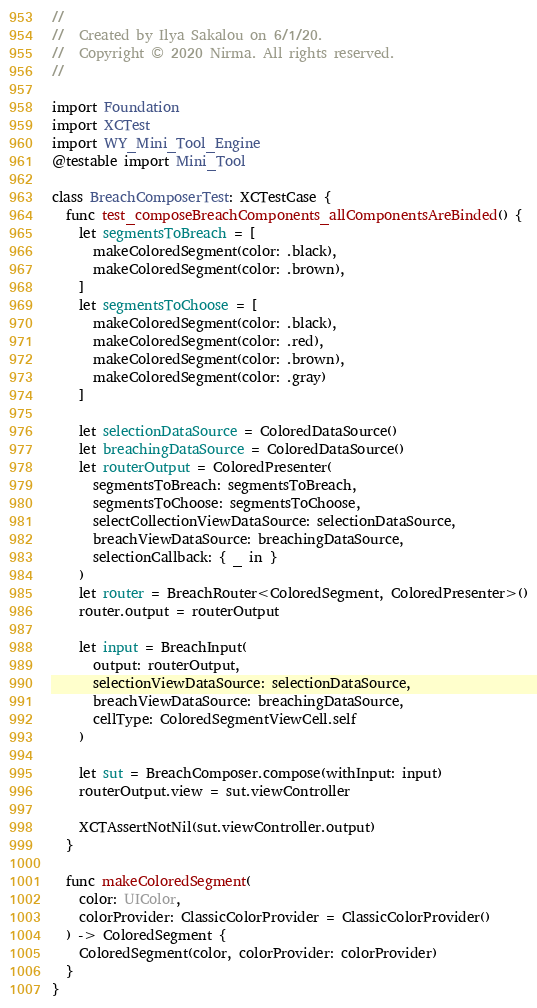<code> <loc_0><loc_0><loc_500><loc_500><_Swift_>//
//  Created by Ilya Sakalou on 6/1/20.
//  Copyright © 2020 Nirma. All rights reserved.
//

import Foundation
import XCTest
import WY_Mini_Tool_Engine
@testable import Mini_Tool

class BreachComposerTest: XCTestCase {
  func test_composeBreachComponents_allComponentsAreBinded() {
    let segmentsToBreach = [
      makeColoredSegment(color: .black),
      makeColoredSegment(color: .brown),
    ]
    let segmentsToChoose = [
      makeColoredSegment(color: .black),
      makeColoredSegment(color: .red),
      makeColoredSegment(color: .brown),
      makeColoredSegment(color: .gray)
    ]
    
    let selectionDataSource = ColoredDataSource()
    let breachingDataSource = ColoredDataSource()
    let routerOutput = ColoredPresenter(
      segmentsToBreach: segmentsToBreach,
      segmentsToChoose: segmentsToChoose,
      selectCollectionViewDataSource: selectionDataSource,
      breachViewDataSource: breachingDataSource,
      selectionCallback: { _ in }
    )
    let router = BreachRouter<ColoredSegment, ColoredPresenter>()
    router.output = routerOutput

    let input = BreachInput(
      output: routerOutput,
      selectionViewDataSource: selectionDataSource,
      breachViewDataSource: breachingDataSource,
      cellType: ColoredSegmentViewCell.self
    )
    
    let sut = BreachComposer.compose(withInput: input)
    routerOutput.view = sut.viewController
    
    XCTAssertNotNil(sut.viewController.output)
  }
  
  func makeColoredSegment(
    color: UIColor,
    colorProvider: ClassicColorProvider = ClassicColorProvider()
  ) -> ColoredSegment {
    ColoredSegment(color, colorProvider: colorProvider)
  }
}
</code> 